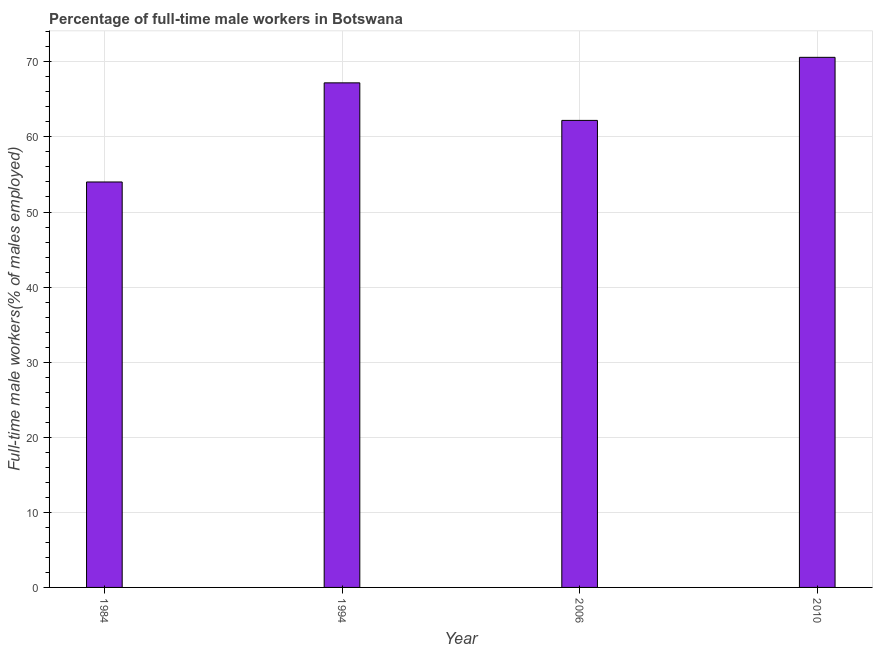Does the graph contain any zero values?
Offer a very short reply. No. Does the graph contain grids?
Offer a very short reply. Yes. What is the title of the graph?
Your answer should be compact. Percentage of full-time male workers in Botswana. What is the label or title of the Y-axis?
Keep it short and to the point. Full-time male workers(% of males employed). What is the percentage of full-time male workers in 1984?
Keep it short and to the point. 54. Across all years, what is the maximum percentage of full-time male workers?
Make the answer very short. 70.6. Across all years, what is the minimum percentage of full-time male workers?
Give a very brief answer. 54. What is the sum of the percentage of full-time male workers?
Your answer should be very brief. 254. What is the average percentage of full-time male workers per year?
Your response must be concise. 63.5. What is the median percentage of full-time male workers?
Provide a short and direct response. 64.7. In how many years, is the percentage of full-time male workers greater than 32 %?
Keep it short and to the point. 4. What is the difference between the highest and the second highest percentage of full-time male workers?
Give a very brief answer. 3.4. Is the sum of the percentage of full-time male workers in 1984 and 2010 greater than the maximum percentage of full-time male workers across all years?
Make the answer very short. Yes. What is the difference between the highest and the lowest percentage of full-time male workers?
Provide a short and direct response. 16.6. Are the values on the major ticks of Y-axis written in scientific E-notation?
Your response must be concise. No. What is the Full-time male workers(% of males employed) in 1994?
Offer a terse response. 67.2. What is the Full-time male workers(% of males employed) in 2006?
Provide a short and direct response. 62.2. What is the Full-time male workers(% of males employed) in 2010?
Make the answer very short. 70.6. What is the difference between the Full-time male workers(% of males employed) in 1984 and 2006?
Offer a terse response. -8.2. What is the difference between the Full-time male workers(% of males employed) in 1984 and 2010?
Offer a terse response. -16.6. What is the difference between the Full-time male workers(% of males employed) in 2006 and 2010?
Keep it short and to the point. -8.4. What is the ratio of the Full-time male workers(% of males employed) in 1984 to that in 1994?
Provide a short and direct response. 0.8. What is the ratio of the Full-time male workers(% of males employed) in 1984 to that in 2006?
Provide a succinct answer. 0.87. What is the ratio of the Full-time male workers(% of males employed) in 1984 to that in 2010?
Provide a short and direct response. 0.77. What is the ratio of the Full-time male workers(% of males employed) in 1994 to that in 2006?
Your response must be concise. 1.08. What is the ratio of the Full-time male workers(% of males employed) in 2006 to that in 2010?
Give a very brief answer. 0.88. 